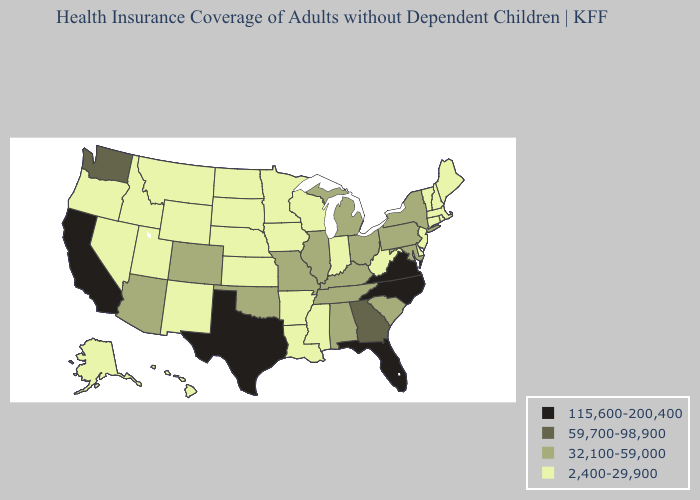What is the lowest value in states that border Louisiana?
Give a very brief answer. 2,400-29,900. Does Texas have the highest value in the South?
Write a very short answer. Yes. What is the lowest value in states that border Ohio?
Concise answer only. 2,400-29,900. Which states hav the highest value in the Northeast?
Be succinct. New York, Pennsylvania. What is the highest value in the USA?
Be succinct. 115,600-200,400. What is the value of Nevada?
Keep it brief. 2,400-29,900. Name the states that have a value in the range 59,700-98,900?
Short answer required. Georgia, Washington. Which states have the highest value in the USA?
Quick response, please. California, Florida, North Carolina, Texas, Virginia. How many symbols are there in the legend?
Quick response, please. 4. Does the first symbol in the legend represent the smallest category?
Concise answer only. No. How many symbols are there in the legend?
Quick response, please. 4. Does Virginia have the same value as West Virginia?
Short answer required. No. Does the first symbol in the legend represent the smallest category?
Keep it brief. No. Name the states that have a value in the range 32,100-59,000?
Short answer required. Alabama, Arizona, Colorado, Illinois, Kentucky, Maryland, Michigan, Missouri, New York, Ohio, Oklahoma, Pennsylvania, South Carolina, Tennessee. 